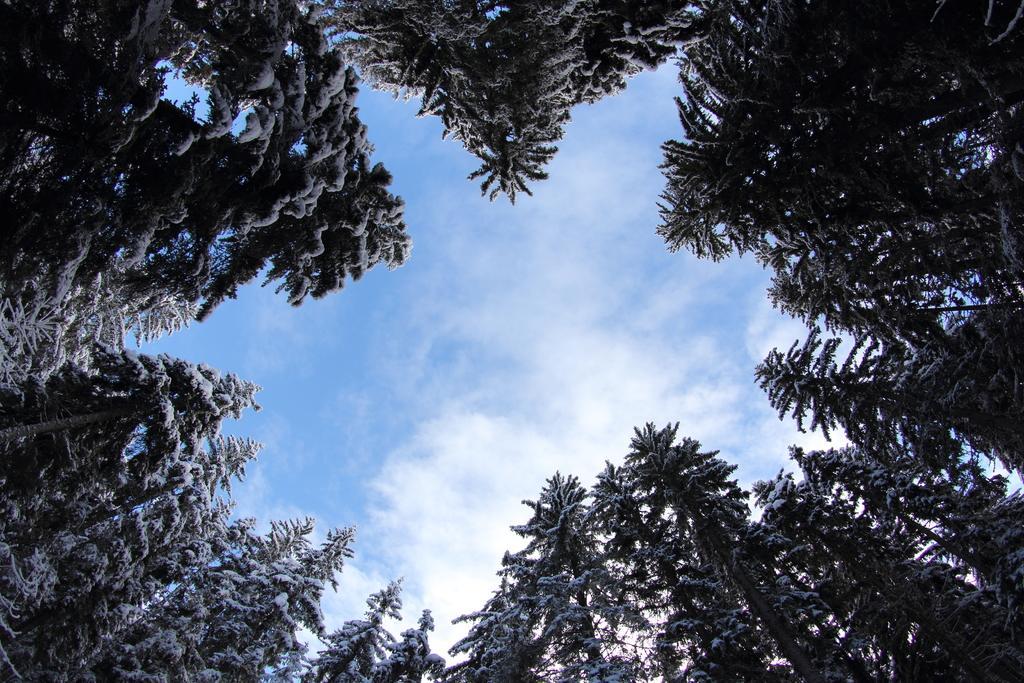Describe this image in one or two sentences. This is a lower view of an image where we can see trees covered with snow and the blue color sky with clouds. 